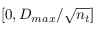<formula> <loc_0><loc_0><loc_500><loc_500>[ 0 , D _ { \max } / \sqrt { n _ { t } } ]</formula> 